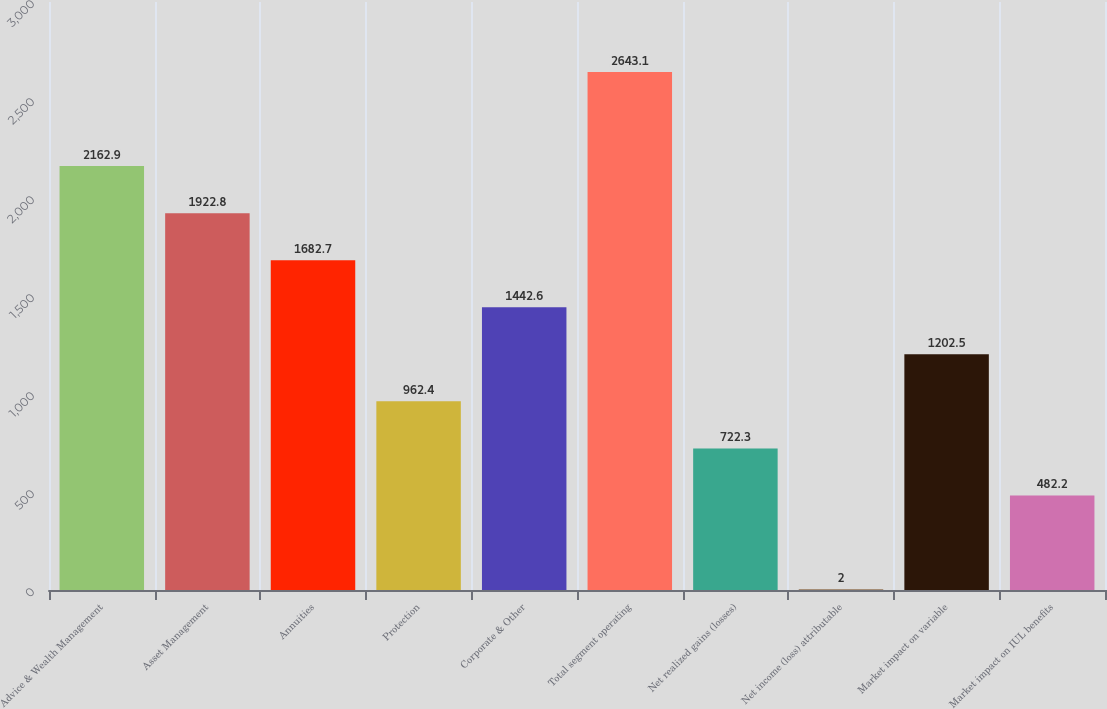Convert chart. <chart><loc_0><loc_0><loc_500><loc_500><bar_chart><fcel>Advice & Wealth Management<fcel>Asset Management<fcel>Annuities<fcel>Protection<fcel>Corporate & Other<fcel>Total segment operating<fcel>Net realized gains (losses)<fcel>Net income (loss) attributable<fcel>Market impact on variable<fcel>Market impact on IUL benefits<nl><fcel>2162.9<fcel>1922.8<fcel>1682.7<fcel>962.4<fcel>1442.6<fcel>2643.1<fcel>722.3<fcel>2<fcel>1202.5<fcel>482.2<nl></chart> 